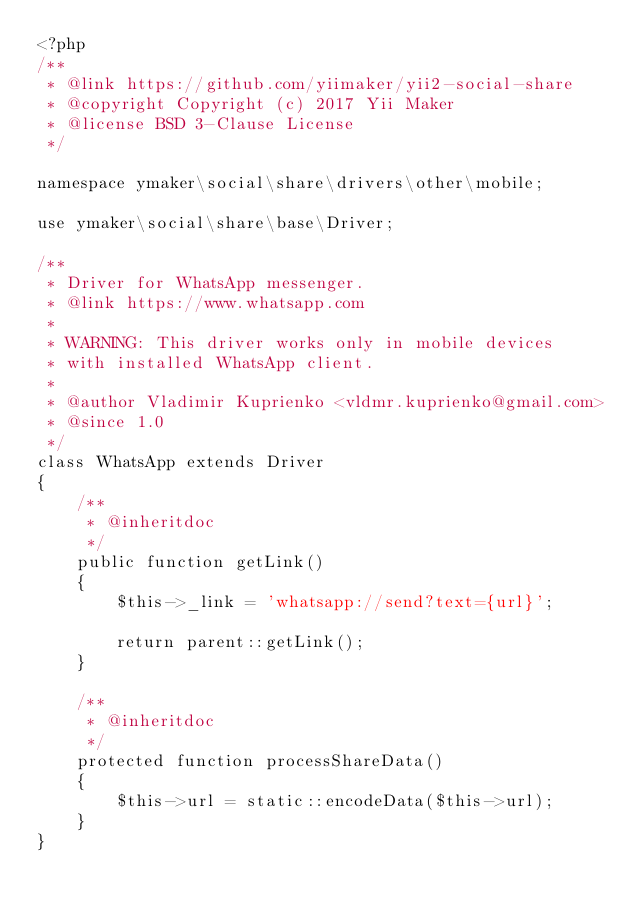Convert code to text. <code><loc_0><loc_0><loc_500><loc_500><_PHP_><?php
/**
 * @link https://github.com/yiimaker/yii2-social-share
 * @copyright Copyright (c) 2017 Yii Maker
 * @license BSD 3-Clause License
 */

namespace ymaker\social\share\drivers\other\mobile;

use ymaker\social\share\base\Driver;

/**
 * Driver for WhatsApp messenger.
 * @link https://www.whatsapp.com
 *
 * WARNING: This driver works only in mobile devices
 * with installed WhatsApp client.
 *
 * @author Vladimir Kuprienko <vldmr.kuprienko@gmail.com>
 * @since 1.0
 */
class WhatsApp extends Driver
{
    /**
     * @inheritdoc
     */
    public function getLink()
    {
        $this->_link = 'whatsapp://send?text={url}';

        return parent::getLink();
    }

    /**
     * @inheritdoc
     */
    protected function processShareData()
    {
        $this->url = static::encodeData($this->url);
    }
}
</code> 